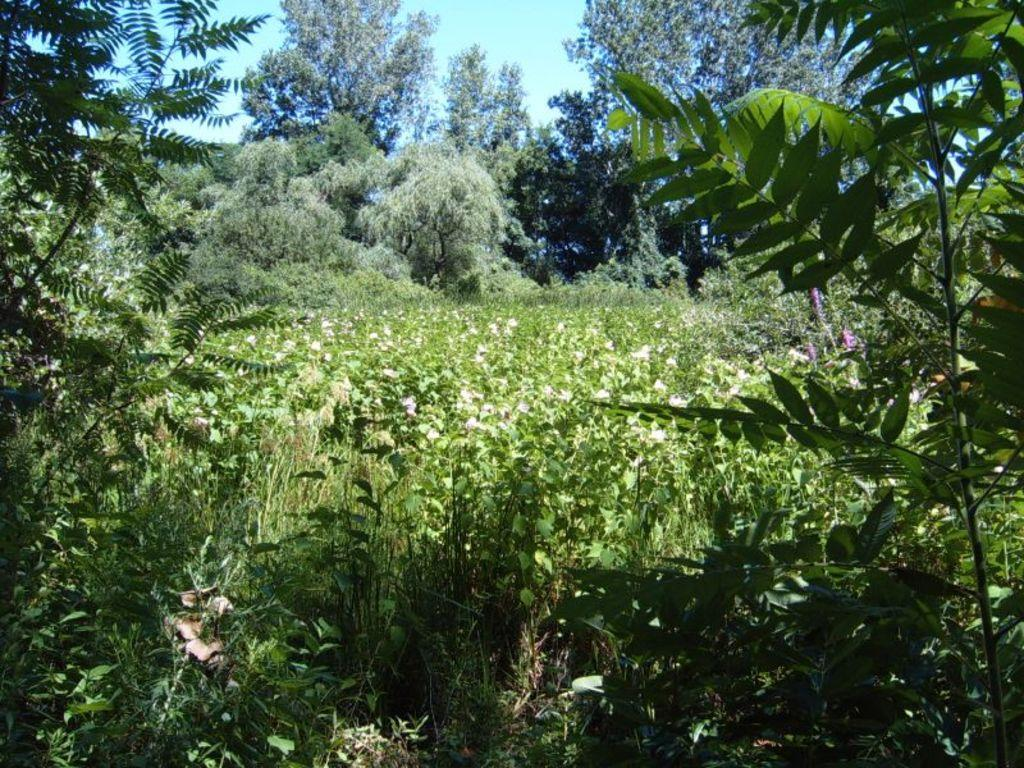What types of vegetation are in the foreground of the image? There are plants and trees in the foreground of the image. What types of vegetation are in the background of the image? There are flowers, additional trees, and plants in the background of the image. What can be seen in the sky in the background of the image? The sky is visible in the background of the image. What is the name of the drum being played in the image? There is no drum present in the image; it features plants, trees, flowers, and the sky. 